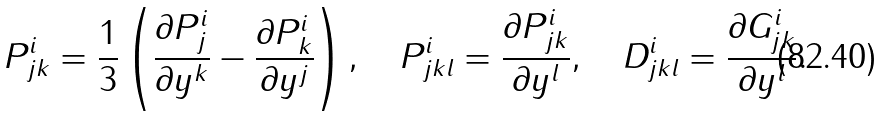<formula> <loc_0><loc_0><loc_500><loc_500>P _ { j k } ^ { i } = \frac { 1 } { 3 } \left ( \frac { \partial P _ { j } ^ { i } } { \partial y ^ { k } } - \frac { \partial P _ { k } ^ { i } } { \partial y ^ { j } } \right ) , \quad P _ { j k l } ^ { i } = \frac { \partial P _ { j k } ^ { i } } { \partial y ^ { l } } , \quad D _ { j k l } ^ { i } = \frac { \partial G _ { j k } ^ { i } } { \partial y ^ { l } } .</formula> 